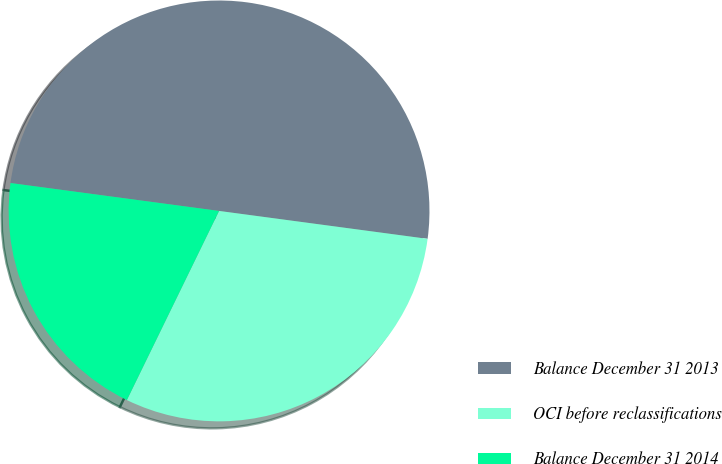Convert chart. <chart><loc_0><loc_0><loc_500><loc_500><pie_chart><fcel>Balance December 31 2013<fcel>OCI before reclassifications<fcel>Balance December 31 2014<nl><fcel>50.0%<fcel>30.1%<fcel>19.9%<nl></chart> 